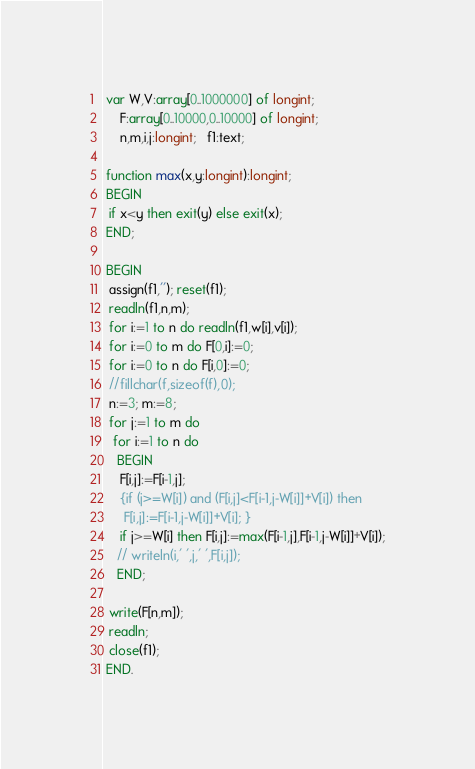Convert code to text. <code><loc_0><loc_0><loc_500><loc_500><_Pascal_> var W,V:array[0..1000000] of longint;
     F:array[0..10000,0..10000] of longint;
     n,m,i,j:longint;   f1:text;

 function max(x,y:longint):longint;
 BEGIN
  if x<y then exit(y) else exit(x);
 END;

 BEGIN
  assign(f1,''); reset(f1);
  readln(f1,n,m);
  for i:=1 to n do readln(f1,w[i],v[i]);
  for i:=0 to m do F[0,i]:=0;
  for i:=0 to n do F[i,0]:=0;
  //fillchar(f,sizeof(f),0);
  n:=3; m:=8;
  for j:=1 to m do
   for i:=1 to n do
    BEGIN
     F[i,j]:=F[i-1,j];
     {if (j>=W[i]) and (F[i,j]<F[i-1,j-W[i]]+V[i]) then
      F[i,j]:=F[i-1,j-W[i]]+V[i]; }
     if j>=W[i] then F[i,j]:=max(F[i-1,j],F[i-1,j-W[i]]+V[i]);
    // writeln(i,' ',j,' ',F[i,j]);
    END;

  write(F[n,m]);
  readln;
  close(f1);
 END.

</code> 